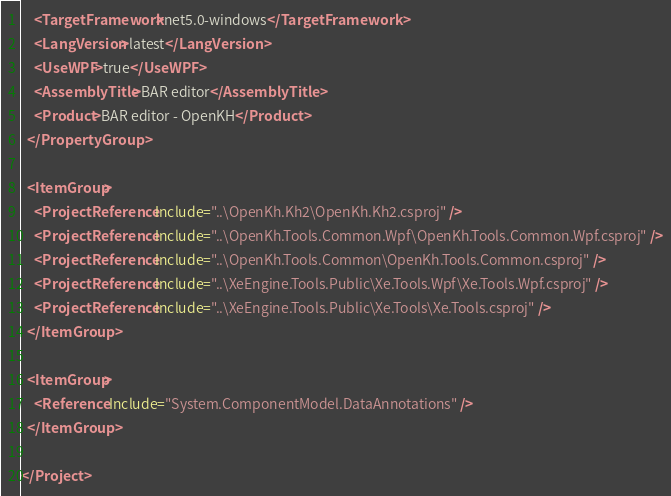<code> <loc_0><loc_0><loc_500><loc_500><_XML_>    <TargetFramework>net5.0-windows</TargetFramework>
    <LangVersion>latest</LangVersion>
    <UseWPF>true</UseWPF>
    <AssemblyTitle>BAR editor</AssemblyTitle>
    <Product>BAR editor - OpenKH</Product>
  </PropertyGroup>
  
  <ItemGroup>
    <ProjectReference Include="..\OpenKh.Kh2\OpenKh.Kh2.csproj" />
    <ProjectReference Include="..\OpenKh.Tools.Common.Wpf\OpenKh.Tools.Common.Wpf.csproj" />
    <ProjectReference Include="..\OpenKh.Tools.Common\OpenKh.Tools.Common.csproj" />
    <ProjectReference Include="..\XeEngine.Tools.Public\Xe.Tools.Wpf\Xe.Tools.Wpf.csproj" />
    <ProjectReference Include="..\XeEngine.Tools.Public\Xe.Tools\Xe.Tools.csproj" />
  </ItemGroup>
  
  <ItemGroup>
    <Reference Include="System.ComponentModel.DataAnnotations" />
  </ItemGroup>
  
</Project></code> 